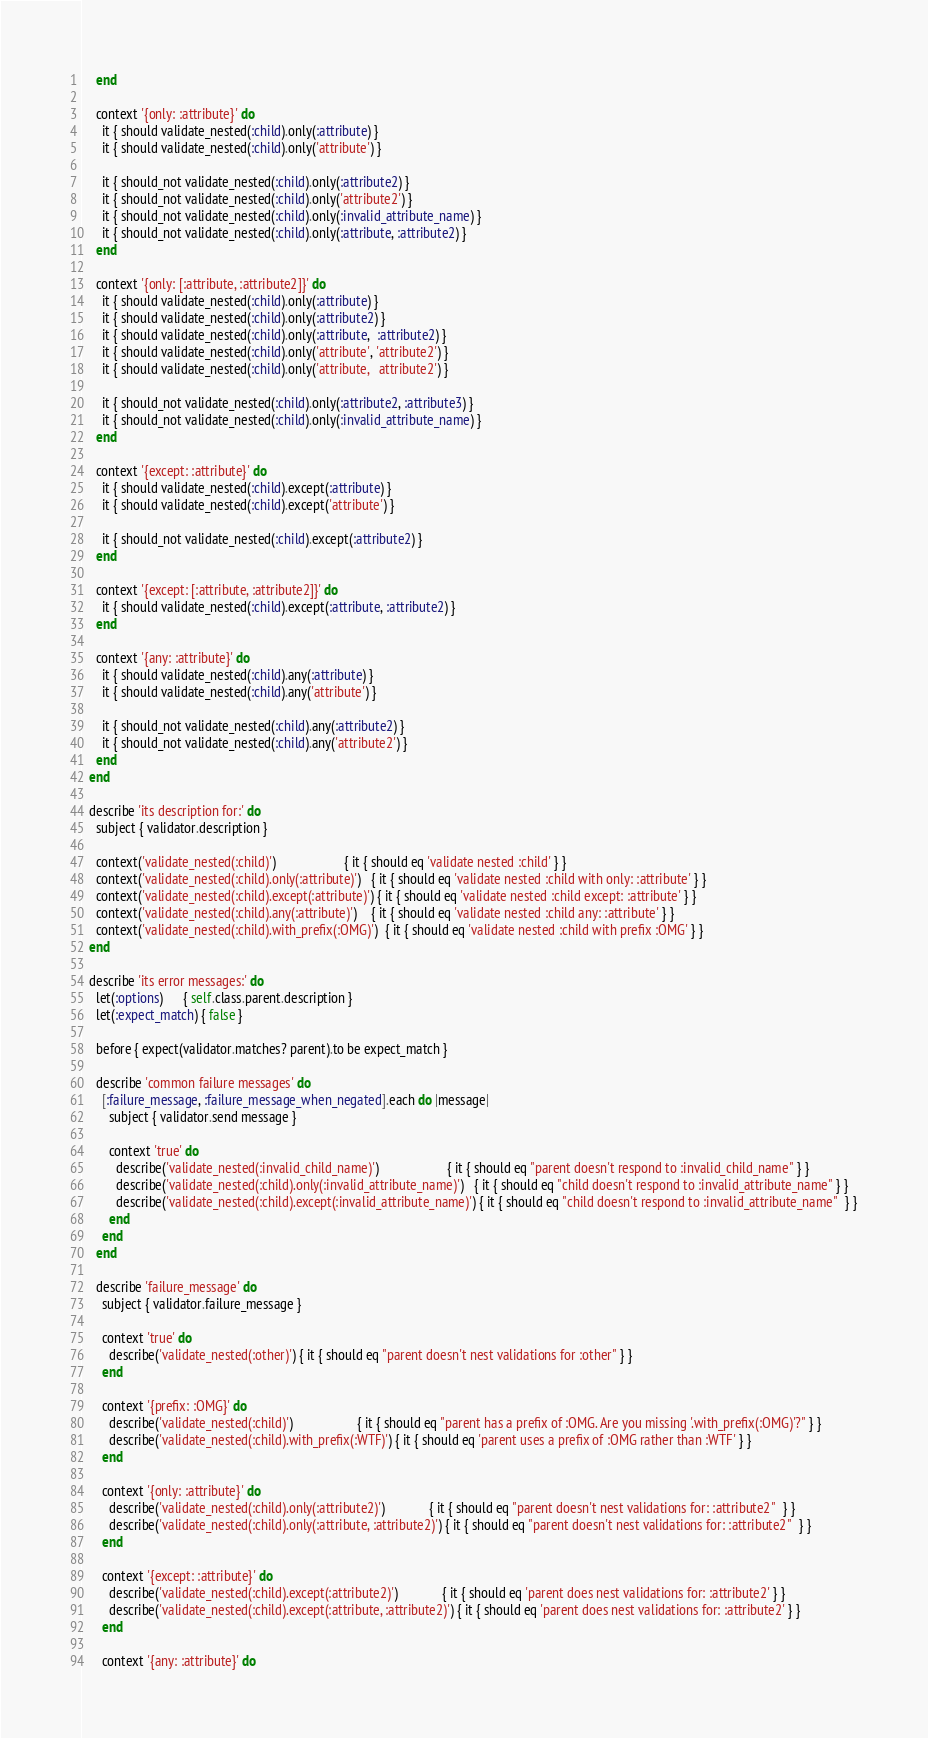<code> <loc_0><loc_0><loc_500><loc_500><_Ruby_>    end

    context '{only: :attribute}' do
      it { should validate_nested(:child).only(:attribute) }
      it { should validate_nested(:child).only('attribute') }

      it { should_not validate_nested(:child).only(:attribute2) }
      it { should_not validate_nested(:child).only('attribute2') }
      it { should_not validate_nested(:child).only(:invalid_attribute_name) }
      it { should_not validate_nested(:child).only(:attribute, :attribute2) }
    end

    context '{only: [:attribute, :attribute2]}' do
      it { should validate_nested(:child).only(:attribute) }
      it { should validate_nested(:child).only(:attribute2) }
      it { should validate_nested(:child).only(:attribute,  :attribute2) }
      it { should validate_nested(:child).only('attribute', 'attribute2') }
      it { should validate_nested(:child).only('attribute,   attribute2') }

      it { should_not validate_nested(:child).only(:attribute2, :attribute3) }
      it { should_not validate_nested(:child).only(:invalid_attribute_name) }
    end

    context '{except: :attribute}' do
      it { should validate_nested(:child).except(:attribute) }
      it { should validate_nested(:child).except('attribute') }

      it { should_not validate_nested(:child).except(:attribute2) }
    end

    context '{except: [:attribute, :attribute2]}' do
      it { should validate_nested(:child).except(:attribute, :attribute2) }
    end

    context '{any: :attribute}' do
      it { should validate_nested(:child).any(:attribute) }
      it { should validate_nested(:child).any('attribute') }

      it { should_not validate_nested(:child).any(:attribute2) }
      it { should_not validate_nested(:child).any('attribute2') }
    end
  end

  describe 'its description for:' do
    subject { validator.description }

    context('validate_nested(:child)')                    { it { should eq 'validate nested :child' } }
    context('validate_nested(:child).only(:attribute)')   { it { should eq 'validate nested :child with only: :attribute' } }
    context('validate_nested(:child).except(:attribute)') { it { should eq 'validate nested :child except: :attribute' } }
    context('validate_nested(:child).any(:attribute)')    { it { should eq 'validate nested :child any: :attribute' } }
    context('validate_nested(:child).with_prefix(:OMG)')  { it { should eq 'validate nested :child with prefix :OMG' } }
  end

  describe 'its error messages:' do
    let(:options)      { self.class.parent.description }
    let(:expect_match) { false }

    before { expect(validator.matches? parent).to be expect_match }

    describe 'common failure messages' do
      [:failure_message, :failure_message_when_negated].each do |message|
        subject { validator.send message }

        context 'true' do
          describe('validate_nested(:invalid_child_name)')                    { it { should eq "parent doesn't respond to :invalid_child_name" } }
          describe('validate_nested(:child).only(:invalid_attribute_name)')   { it { should eq "child doesn't respond to :invalid_attribute_name" } }
          describe('validate_nested(:child).except(:invalid_attribute_name)') { it { should eq "child doesn't respond to :invalid_attribute_name"  } }
        end
      end
    end

    describe 'failure_message' do
      subject { validator.failure_message }

      context 'true' do
        describe('validate_nested(:other)') { it { should eq "parent doesn't nest validations for :other" } }
      end

      context '{prefix: :OMG}' do
        describe('validate_nested(:child)')                   { it { should eq "parent has a prefix of :OMG. Are you missing '.with_prefix(:OMG)'?" } }
        describe('validate_nested(:child).with_prefix(:WTF)') { it { should eq 'parent uses a prefix of :OMG rather than :WTF' } }
      end

      context '{only: :attribute}' do
        describe('validate_nested(:child).only(:attribute2)')             { it { should eq "parent doesn't nest validations for: :attribute2"  } }
        describe('validate_nested(:child).only(:attribute, :attribute2)') { it { should eq "parent doesn't nest validations for: :attribute2"  } }
      end

      context '{except: :attribute}' do
        describe('validate_nested(:child).except(:attribute2)')             { it { should eq 'parent does nest validations for: :attribute2' } }
        describe('validate_nested(:child).except(:attribute, :attribute2)') { it { should eq 'parent does nest validations for: :attribute2' } }
      end

      context '{any: :attribute}' do</code> 